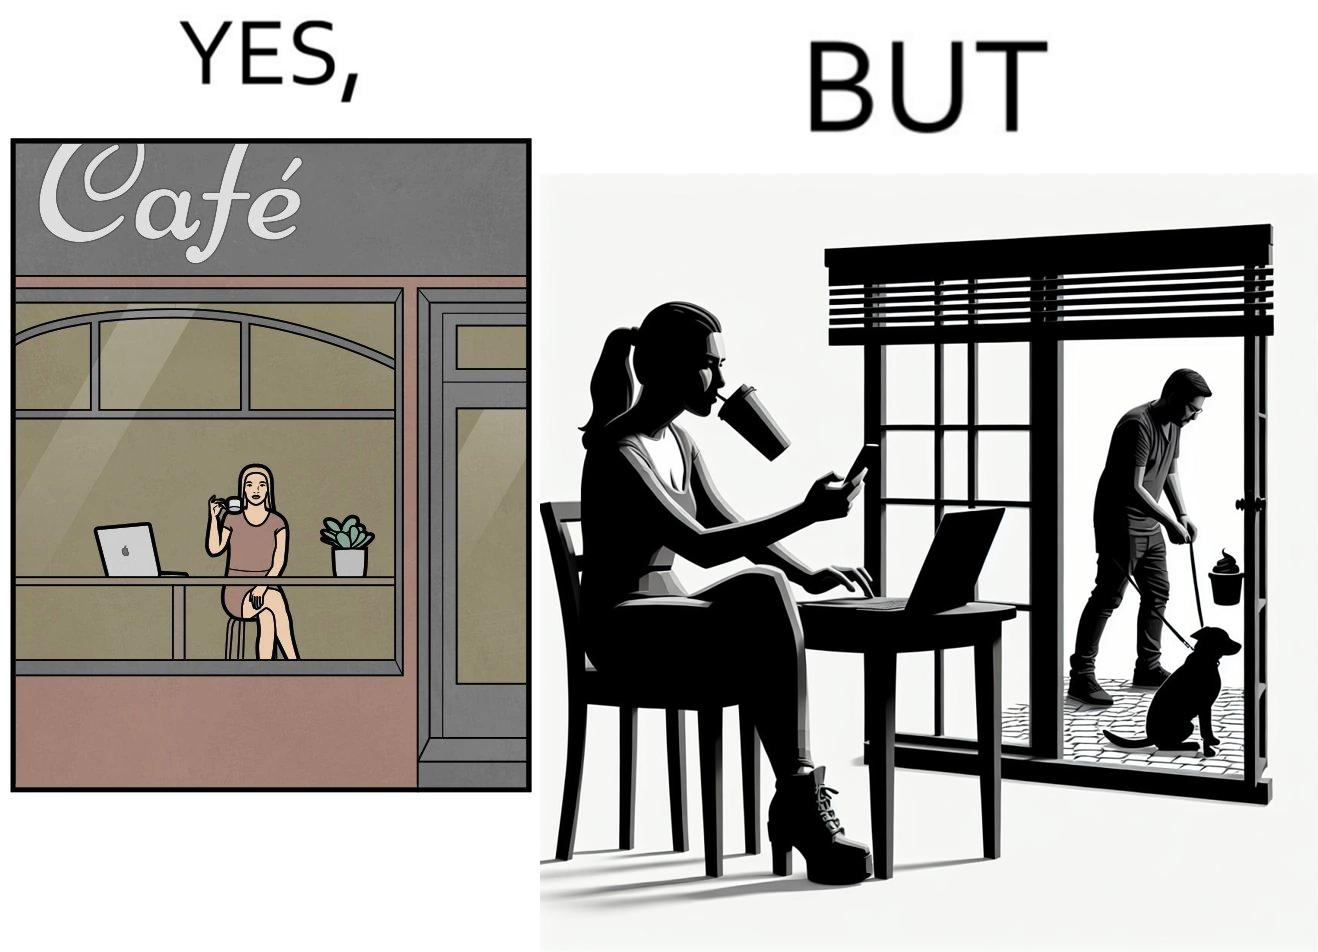Would you classify this image as satirical? Yes, this image is satirical. 